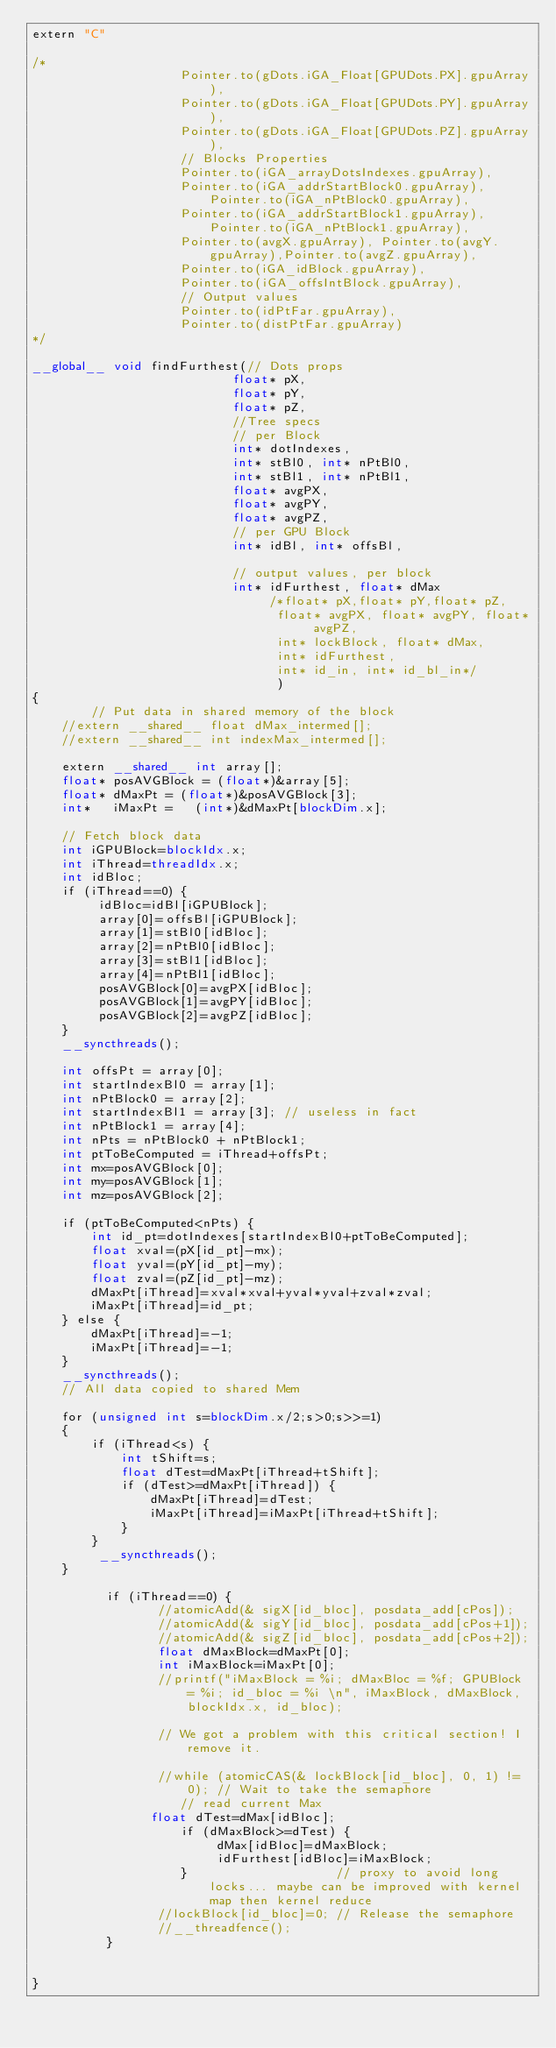<code> <loc_0><loc_0><loc_500><loc_500><_Cuda_>extern "C"

/*
                    Pointer.to(gDots.iGA_Float[GPUDots.PX].gpuArray), 
                    Pointer.to(gDots.iGA_Float[GPUDots.PY].gpuArray),
                    Pointer.to(gDots.iGA_Float[GPUDots.PZ].gpuArray),
                    // Blocks Properties
                    Pointer.to(iGA_arrayDotsIndexes.gpuArray),
                    Pointer.to(iGA_addrStartBlock0.gpuArray),Pointer.to(iGA_nPtBlock0.gpuArray),
                    Pointer.to(iGA_addrStartBlock1.gpuArray),Pointer.to(iGA_nPtBlock1.gpuArray),
                    Pointer.to(avgX.gpuArray), Pointer.to(avgY.gpuArray),Pointer.to(avgZ.gpuArray),
                    Pointer.to(iGA_idBlock.gpuArray),
                    Pointer.to(iGA_offsIntBlock.gpuArray),   
                    // Output values
                    Pointer.to(idPtFar.gpuArray),
                    Pointer.to(distPtFar.gpuArray)
*/

__global__ void findFurthest(// Dots props
						   float* pX,
                           float* pY,
                           float* pZ,
						   //Tree specs
						   // per Block
						   int* dotIndexes, 
                           int* stBl0, int* nPtBl0,
						   int* stBl1, int* nPtBl1,
						   float* avgPX, 
                           float* avgPY,
                           float* avgPZ,
						   // per GPU Block
						   int* idBl, int* offsBl,
						   
						   // output values, per block
						   int* idFurthest, float* dMax
								/*float* pX,float* pY,float* pZ, 
                                 float* avgPX, float* avgPY, float* avgPZ,
                                 int* lockBlock, float* dMax, 
                                 int* idFurthest,
                                 int* id_in, int* id_bl_in*/
								 )
{
        // Put data in shared memory of the block
    //extern __shared__ float dMax_intermed[];
    //extern __shared__ int indexMax_intermed[];
    
    extern __shared__ int array[];    
    float* posAVGBlock = (float*)&array[5]; 
    float* dMaxPt = (float*)&posAVGBlock[3];
    int*   iMaxPt =   (int*)&dMaxPt[blockDim.x];    
    
	// Fetch block data
    int iGPUBlock=blockIdx.x;
	int iThread=threadIdx.x;
	int idBloc;
	if (iThread==0) {
		 idBloc=idBl[iGPUBlock];		 
		 array[0]=offsBl[iGPUBlock];
		 array[1]=stBl0[idBloc];
		 array[2]=nPtBl0[idBloc];
		 array[3]=stBl1[idBloc];		 
		 array[4]=nPtBl1[idBloc];
		 posAVGBlock[0]=avgPX[idBloc];
		 posAVGBlock[1]=avgPY[idBloc];
		 posAVGBlock[2]=avgPZ[idBloc];
	}
	__syncthreads();	
	
	int offsPt = array[0];
	int startIndexBl0 = array[1];	 
	int nPtBlock0 = array[2];
	int startIndexBl1 = array[3]; // useless in fact
	int nPtBlock1 = array[4];
	int nPts = nPtBlock0 + nPtBlock1;
	int ptToBeComputed = iThread+offsPt;
	int mx=posAVGBlock[0];
	int my=posAVGBlock[1];
	int mz=posAVGBlock[2];

	if (ptToBeComputed<nPts) {
		int id_pt=dotIndexes[startIndexBl0+ptToBeComputed];
		float xval=(pX[id_pt]-mx);
        float yval=(pY[id_pt]-my);
        float zval=(pZ[id_pt]-mz);                
        dMaxPt[iThread]=xval*xval+yval*yval+zval*zval;
        iMaxPt[iThread]=id_pt;
	} else {
		dMaxPt[iThread]=-1;
        iMaxPt[iThread]=-1;
	}       
    __syncthreads();
    // All data copied to shared Mem
         
    for (unsigned int s=blockDim.x/2;s>0;s>>=1)
    {
        if (iThread<s) {       
            int tShift=s;
            float dTest=dMaxPt[iThread+tShift];
            if (dTest>=dMaxPt[iThread]) {
                dMaxPt[iThread]=dTest;
                iMaxPt[iThread]=iMaxPt[iThread+tShift];  
            }
        }
         __syncthreads();
    }
          
          if (iThread==0) {
                 //atomicAdd(& sigX[id_bloc], posdata_add[cPos]);
                 //atomicAdd(& sigY[id_bloc], posdata_add[cPos+1]);
                 //atomicAdd(& sigZ[id_bloc], posdata_add[cPos+2]);
                 float dMaxBlock=dMaxPt[0];
                 int iMaxBlock=iMaxPt[0];
                 //printf("iMaxBlock = %i; dMaxBloc = %f; GPUBlock = %i; id_bloc = %i \n", iMaxBlock, dMaxBlock, blockIdx.x, id_bloc);
                 
                 // We got a problem with this critical section! I remove it.
                  
                 //while (atomicCAS(& lockBlock[id_bloc], 0, 1) != 0); // Wait to take the semaphore
                    // read current Max
                float dTest=dMax[idBloc];
                    if (dMaxBlock>=dTest) {
                         dMax[idBloc]=dMaxBlock;
                         idFurthest[idBloc]=iMaxBlock;
                    }                    // proxy to avoid long locks... maybe can be improved with kernel map then kernel reduce
                 //lockBlock[id_bloc]=0; // Release the semaphore
                 //__threadfence();
          }         
     
    
}
</code> 